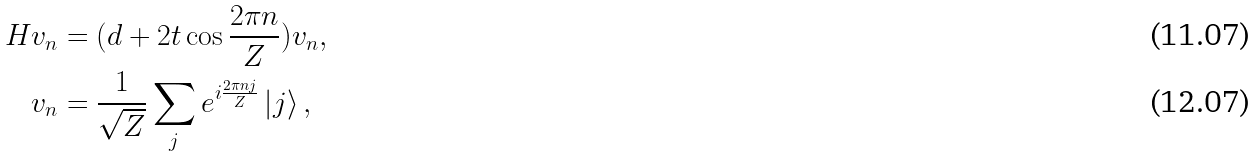Convert formula to latex. <formula><loc_0><loc_0><loc_500><loc_500>H v _ { n } & = ( d + 2 t \cos \frac { 2 \pi n } { Z } ) v _ { n } , \\ v _ { n } & = \frac { 1 } { \sqrt { Z } } \sum _ { j } e ^ { i \frac { 2 \pi n j } { Z } } \left | j \right \rangle ,</formula> 